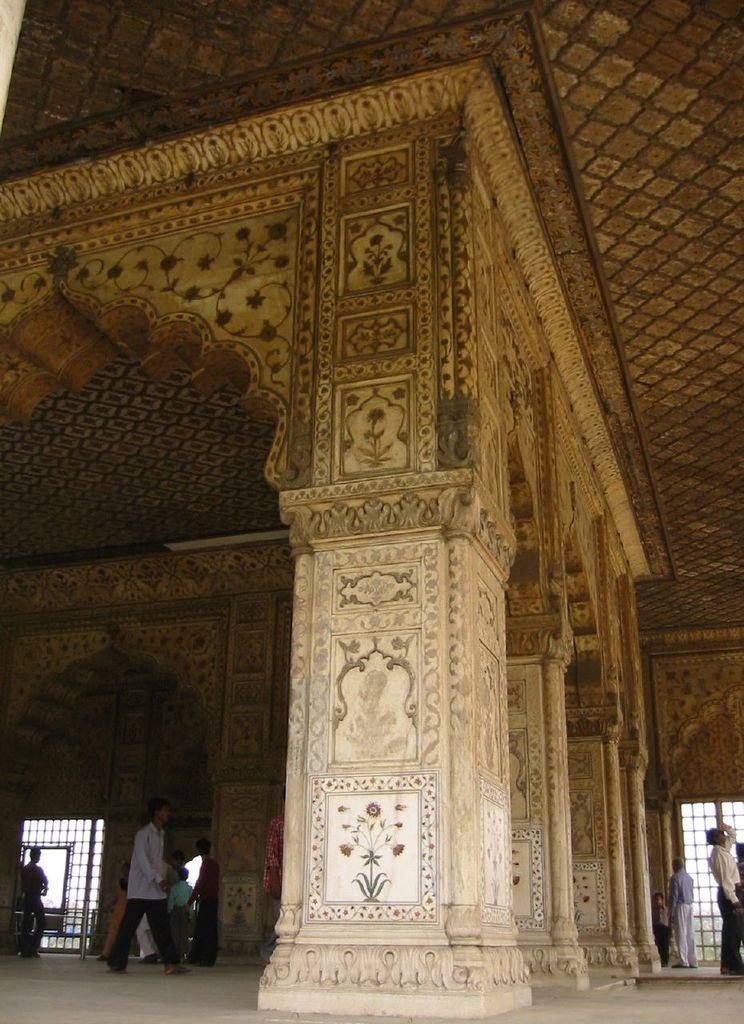Describe this image in one or two sentences. In this picture I can see the inside view of the monument. In the bottom right I can see some persons who are standing on the floor. In the bottom left corner I can see some persons who are walking and standing near to the pillars. Beside them I can see the gate, sky and grass. 